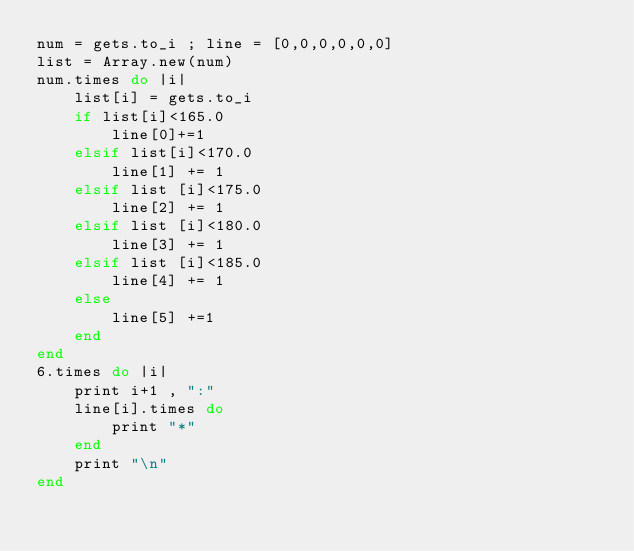Convert code to text. <code><loc_0><loc_0><loc_500><loc_500><_Ruby_>num = gets.to_i ; line = [0,0,0,0,0,0]
list = Array.new(num)
num.times do |i|
	list[i] = gets.to_i
	if list[i]<165.0
		line[0]+=1
	elsif list[i]<170.0
		line[1] += 1
	elsif list [i]<175.0
		line[2] += 1
	elsif list [i]<180.0
		line[3] += 1
	elsif list [i]<185.0
		line[4] += 1
	else 
		line[5] +=1
	end
end
6.times do |i|
	print i+1 , ":"
	line[i].times do 
		print "*"
	end
	print "\n"
end</code> 